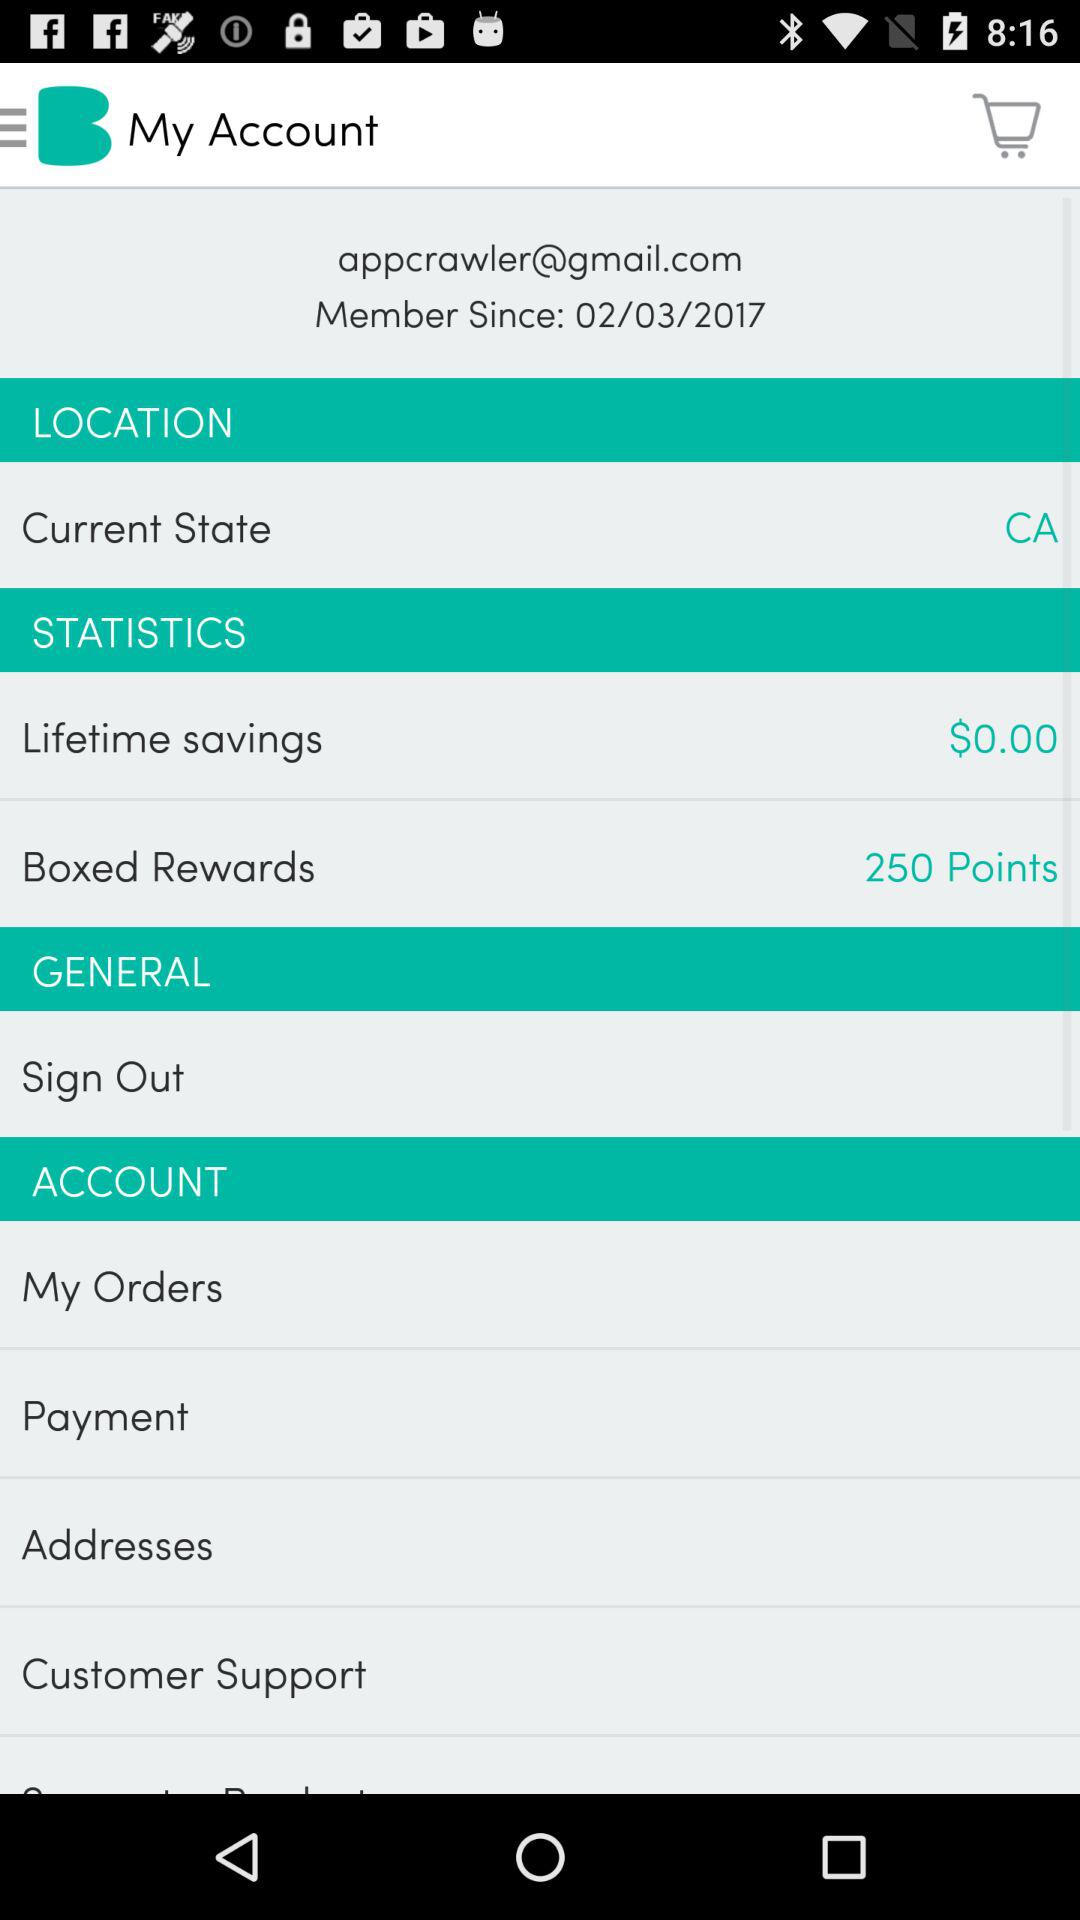What are the lifetime savings? The lifetime savings are $0. 